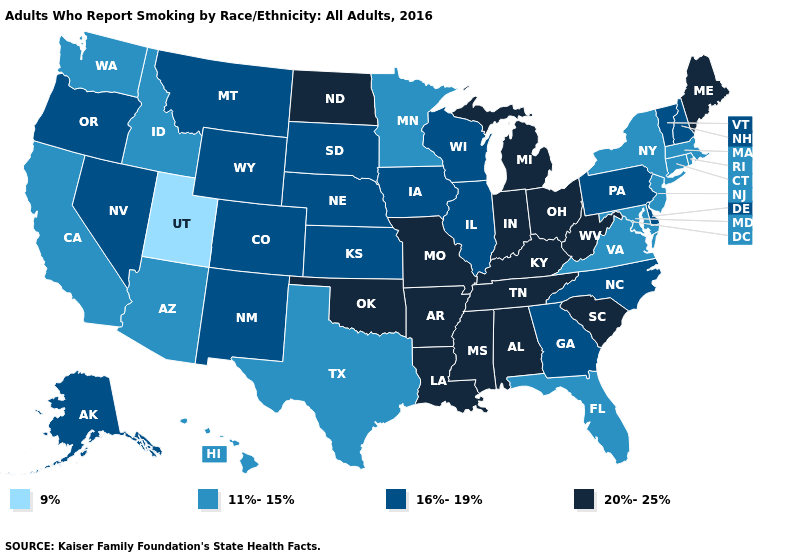Name the states that have a value in the range 9%?
Quick response, please. Utah. Name the states that have a value in the range 11%-15%?
Quick response, please. Arizona, California, Connecticut, Florida, Hawaii, Idaho, Maryland, Massachusetts, Minnesota, New Jersey, New York, Rhode Island, Texas, Virginia, Washington. How many symbols are there in the legend?
Concise answer only. 4. What is the lowest value in the USA?
Give a very brief answer. 9%. Which states have the lowest value in the MidWest?
Write a very short answer. Minnesota. Does Wyoming have the highest value in the USA?
Keep it brief. No. Does Alabama have the highest value in the South?
Keep it brief. Yes. Name the states that have a value in the range 16%-19%?
Answer briefly. Alaska, Colorado, Delaware, Georgia, Illinois, Iowa, Kansas, Montana, Nebraska, Nevada, New Hampshire, New Mexico, North Carolina, Oregon, Pennsylvania, South Dakota, Vermont, Wisconsin, Wyoming. Name the states that have a value in the range 20%-25%?
Answer briefly. Alabama, Arkansas, Indiana, Kentucky, Louisiana, Maine, Michigan, Mississippi, Missouri, North Dakota, Ohio, Oklahoma, South Carolina, Tennessee, West Virginia. Does South Dakota have a lower value than North Dakota?
Short answer required. Yes. What is the lowest value in states that border Texas?
Keep it brief. 16%-19%. What is the lowest value in states that border Kentucky?
Keep it brief. 11%-15%. Name the states that have a value in the range 20%-25%?
Short answer required. Alabama, Arkansas, Indiana, Kentucky, Louisiana, Maine, Michigan, Mississippi, Missouri, North Dakota, Ohio, Oklahoma, South Carolina, Tennessee, West Virginia. Name the states that have a value in the range 16%-19%?
Concise answer only. Alaska, Colorado, Delaware, Georgia, Illinois, Iowa, Kansas, Montana, Nebraska, Nevada, New Hampshire, New Mexico, North Carolina, Oregon, Pennsylvania, South Dakota, Vermont, Wisconsin, Wyoming. Name the states that have a value in the range 11%-15%?
Quick response, please. Arizona, California, Connecticut, Florida, Hawaii, Idaho, Maryland, Massachusetts, Minnesota, New Jersey, New York, Rhode Island, Texas, Virginia, Washington. 